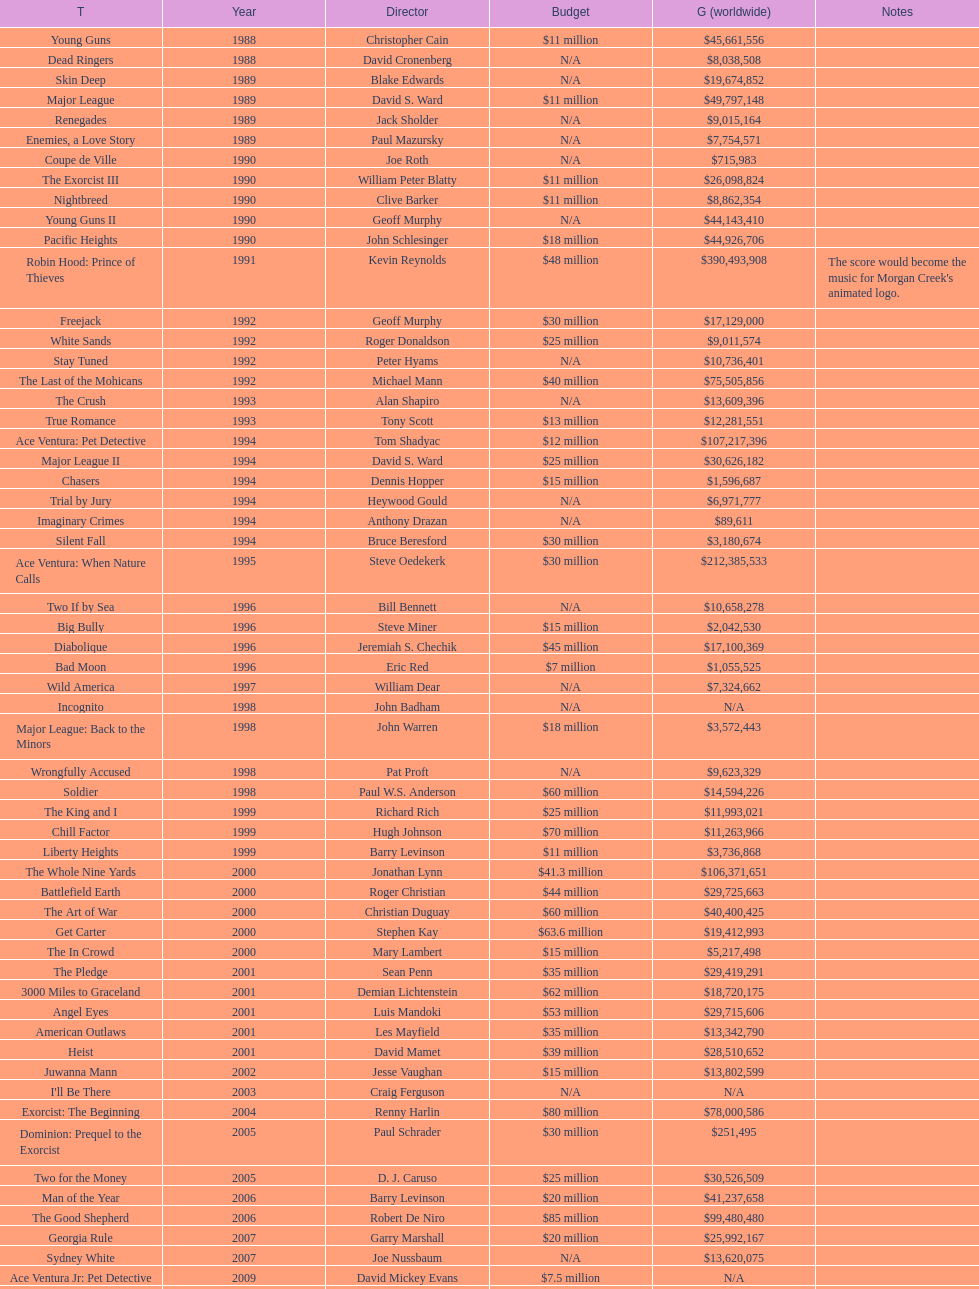Which morgan creek film grossed the most money prior to 1994? Robin Hood: Prince of Thieves. 